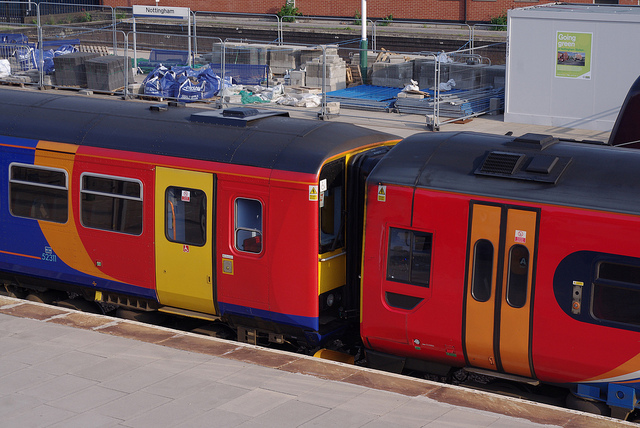Read and extract the text from this image. Going 